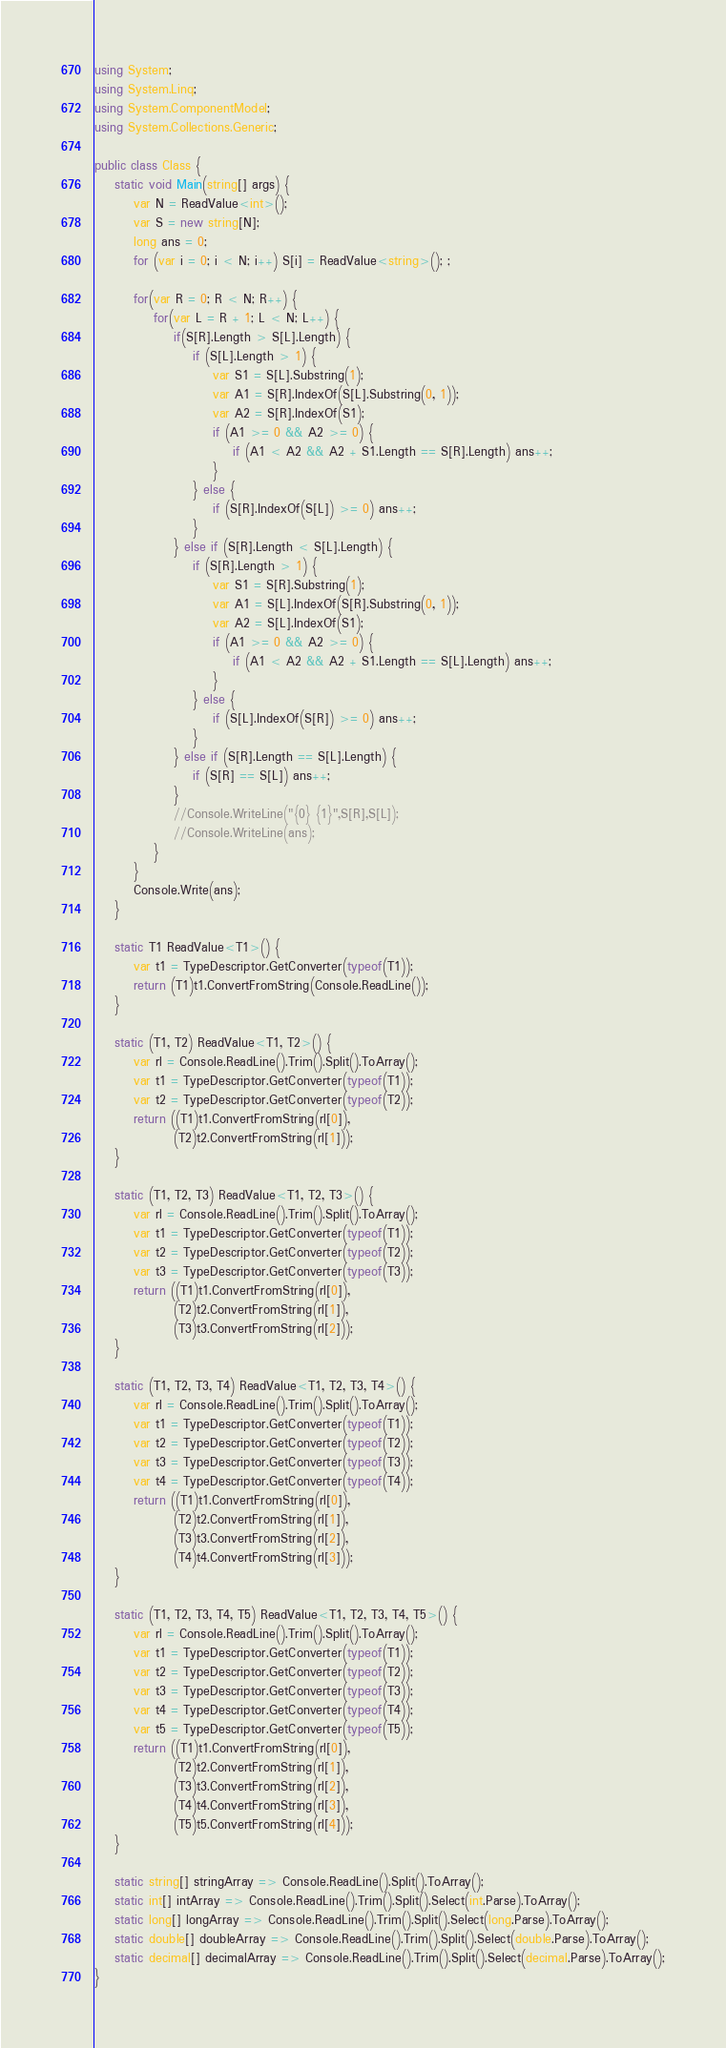Convert code to text. <code><loc_0><loc_0><loc_500><loc_500><_C#_>using System;
using System.Linq;
using System.ComponentModel;
using System.Collections.Generic;

public class Class {
    static void Main(string[] args) {
        var N = ReadValue<int>();
        var S = new string[N];
        long ans = 0;
        for (var i = 0; i < N; i++) S[i] = ReadValue<string>(); ;
        
        for(var R = 0; R < N; R++) {
            for(var L = R + 1; L < N; L++) {
                if(S[R].Length > S[L].Length) {
                    if (S[L].Length > 1) {
                        var S1 = S[L].Substring(1);
                        var A1 = S[R].IndexOf(S[L].Substring(0, 1));
                        var A2 = S[R].IndexOf(S1);
                        if (A1 >= 0 && A2 >= 0) {
                            if (A1 < A2 && A2 + S1.Length == S[R].Length) ans++;
                        }
                    } else {
                        if (S[R].IndexOf(S[L]) >= 0) ans++;
                    }
                } else if (S[R].Length < S[L].Length) {
                    if (S[R].Length > 1) {
                        var S1 = S[R].Substring(1);
                        var A1 = S[L].IndexOf(S[R].Substring(0, 1));
                        var A2 = S[L].IndexOf(S1);
                        if (A1 >= 0 && A2 >= 0) {
                            if (A1 < A2 && A2 + S1.Length == S[L].Length) ans++;
                        }
                    } else {
                        if (S[L].IndexOf(S[R]) >= 0) ans++;
                    }
                } else if (S[R].Length == S[L].Length) {
                    if (S[R] == S[L]) ans++;
                }
                //Console.WriteLine("{0} {1}",S[R],S[L]);
                //Console.WriteLine(ans);
            }
        }
        Console.Write(ans);
    }

    static T1 ReadValue<T1>() {
        var t1 = TypeDescriptor.GetConverter(typeof(T1));
        return (T1)t1.ConvertFromString(Console.ReadLine());
    }

    static (T1, T2) ReadValue<T1, T2>() {
        var rl = Console.ReadLine().Trim().Split().ToArray();
        var t1 = TypeDescriptor.GetConverter(typeof(T1));
        var t2 = TypeDescriptor.GetConverter(typeof(T2));
        return ((T1)t1.ConvertFromString(rl[0]),
                (T2)t2.ConvertFromString(rl[1]));
    }

    static (T1, T2, T3) ReadValue<T1, T2, T3>() {
        var rl = Console.ReadLine().Trim().Split().ToArray();
        var t1 = TypeDescriptor.GetConverter(typeof(T1));
        var t2 = TypeDescriptor.GetConverter(typeof(T2));
        var t3 = TypeDescriptor.GetConverter(typeof(T3));
        return ((T1)t1.ConvertFromString(rl[0]),
                (T2)t2.ConvertFromString(rl[1]),
                (T3)t3.ConvertFromString(rl[2]));
    }

    static (T1, T2, T3, T4) ReadValue<T1, T2, T3, T4>() {
        var rl = Console.ReadLine().Trim().Split().ToArray();
        var t1 = TypeDescriptor.GetConverter(typeof(T1));
        var t2 = TypeDescriptor.GetConverter(typeof(T2));
        var t3 = TypeDescriptor.GetConverter(typeof(T3));
        var t4 = TypeDescriptor.GetConverter(typeof(T4));
        return ((T1)t1.ConvertFromString(rl[0]),
                (T2)t2.ConvertFromString(rl[1]),
                (T3)t3.ConvertFromString(rl[2]),
                (T4)t4.ConvertFromString(rl[3]));
    }

    static (T1, T2, T3, T4, T5) ReadValue<T1, T2, T3, T4, T5>() {
        var rl = Console.ReadLine().Trim().Split().ToArray();
        var t1 = TypeDescriptor.GetConverter(typeof(T1));
        var t2 = TypeDescriptor.GetConverter(typeof(T2));
        var t3 = TypeDescriptor.GetConverter(typeof(T3));
        var t4 = TypeDescriptor.GetConverter(typeof(T4));
        var t5 = TypeDescriptor.GetConverter(typeof(T5));
        return ((T1)t1.ConvertFromString(rl[0]),
                (T2)t2.ConvertFromString(rl[1]),
                (T3)t3.ConvertFromString(rl[2]),
                (T4)t4.ConvertFromString(rl[3]),
                (T5)t5.ConvertFromString(rl[4]));
    }

    static string[] stringArray => Console.ReadLine().Split().ToArray();
    static int[] intArray => Console.ReadLine().Trim().Split().Select(int.Parse).ToArray();
    static long[] longArray => Console.ReadLine().Trim().Split().Select(long.Parse).ToArray();
    static double[] doubleArray => Console.ReadLine().Trim().Split().Select(double.Parse).ToArray();
    static decimal[] decimalArray => Console.ReadLine().Trim().Split().Select(decimal.Parse).ToArray();
}
</code> 